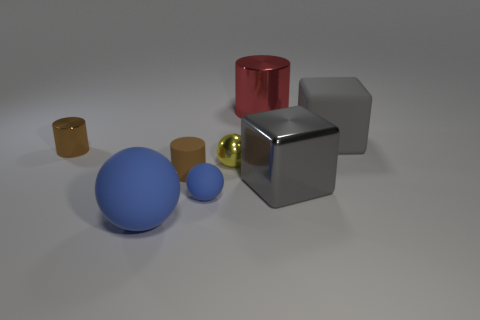Add 1 red spheres. How many objects exist? 9 Subtract all spheres. How many objects are left? 5 Subtract 0 purple blocks. How many objects are left? 8 Subtract all large shiny blocks. Subtract all tiny brown matte cylinders. How many objects are left? 6 Add 3 large red metal cylinders. How many large red metal cylinders are left? 4 Add 8 blue objects. How many blue objects exist? 10 